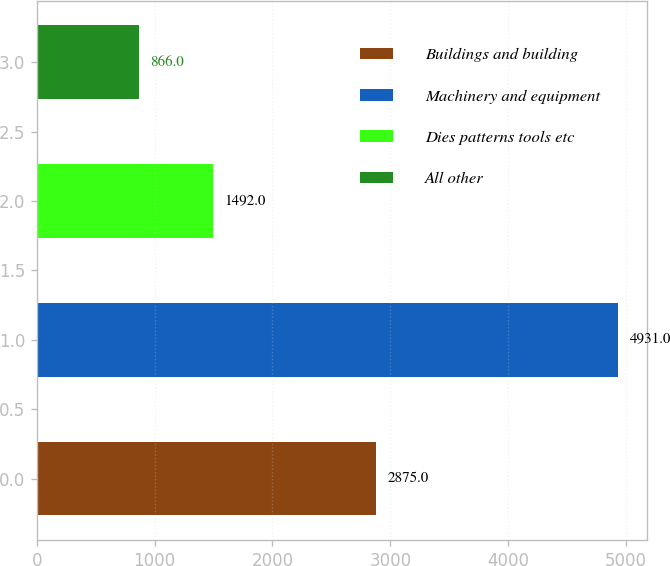<chart> <loc_0><loc_0><loc_500><loc_500><bar_chart><fcel>Buildings and building<fcel>Machinery and equipment<fcel>Dies patterns tools etc<fcel>All other<nl><fcel>2875<fcel>4931<fcel>1492<fcel>866<nl></chart> 